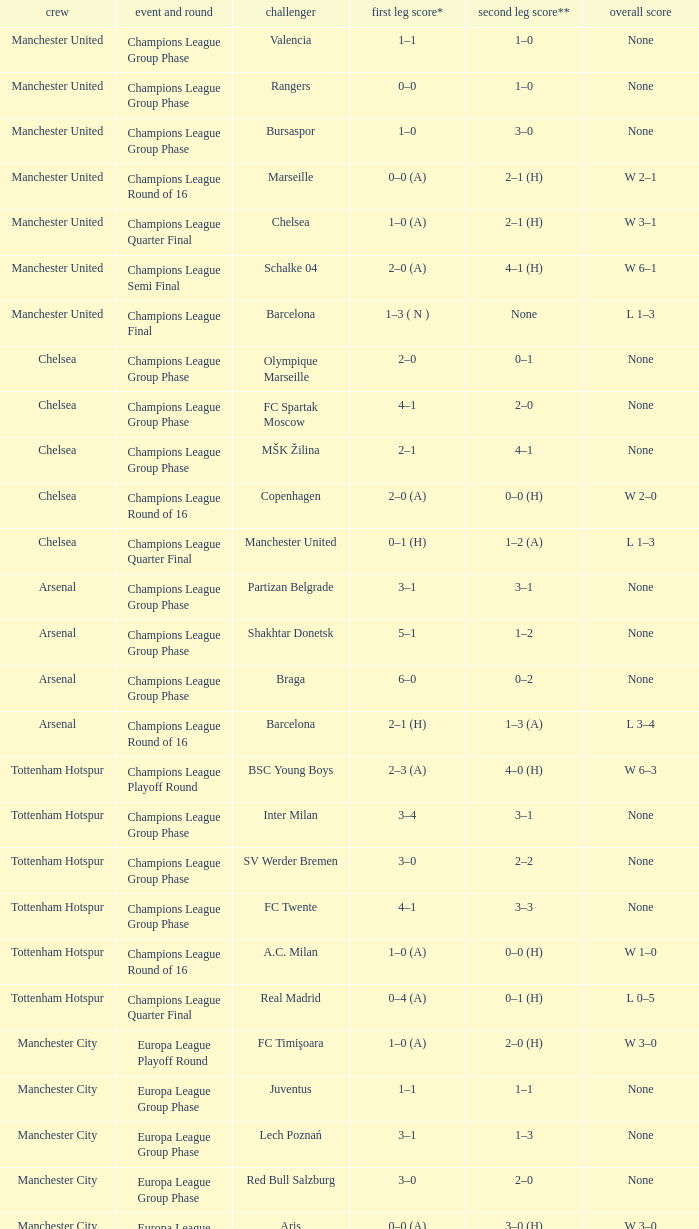How many goals did each one of the teams score in the first leg of the match between Liverpool and Trabzonspor? 1–0 (H). 